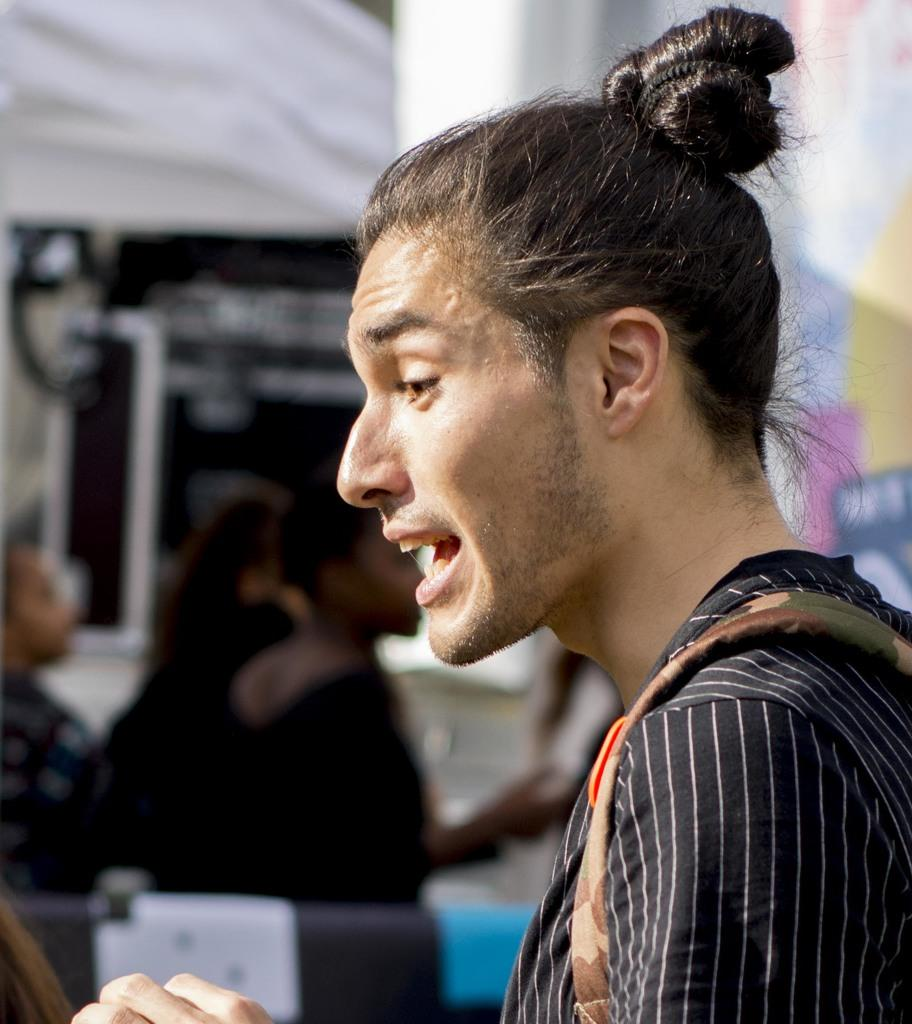How does the harmony between the trees change throughout the image? There are no trees or any indication of harmony in the image, so it is not possible to determine how the harmony between the trees might change. 